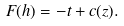Convert formula to latex. <formula><loc_0><loc_0><loc_500><loc_500>F ( h ) = - t + c ( z ) .</formula> 